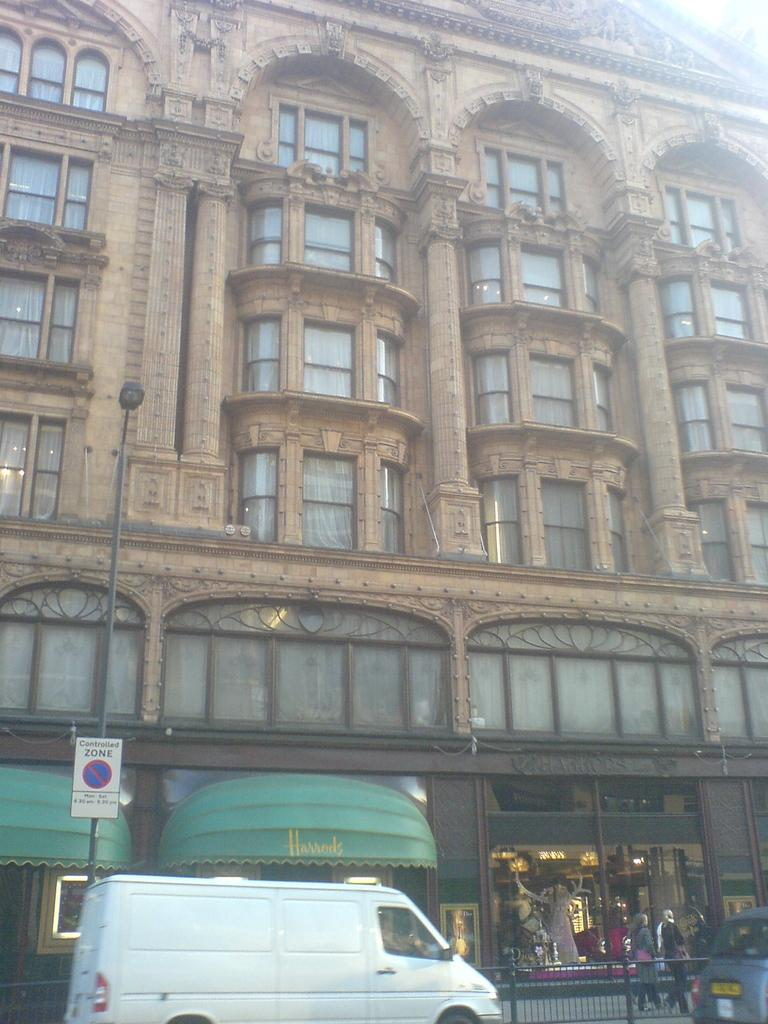What types of objects are located at the bottom of the picture? There are vehicles, a railing, a footpath, a sign board, and people at the bottom of the picture. What can be seen in the center of the picture? There is a building in the center of the picture. Is there any lighting fixture visible in the picture? Yes, there is a street light on the left side of the picture. What type of quilt is being used as a decoration in the picture? There is no quilt present in the image. How many roses can be seen in the picture? There are no roses visible in the image. 